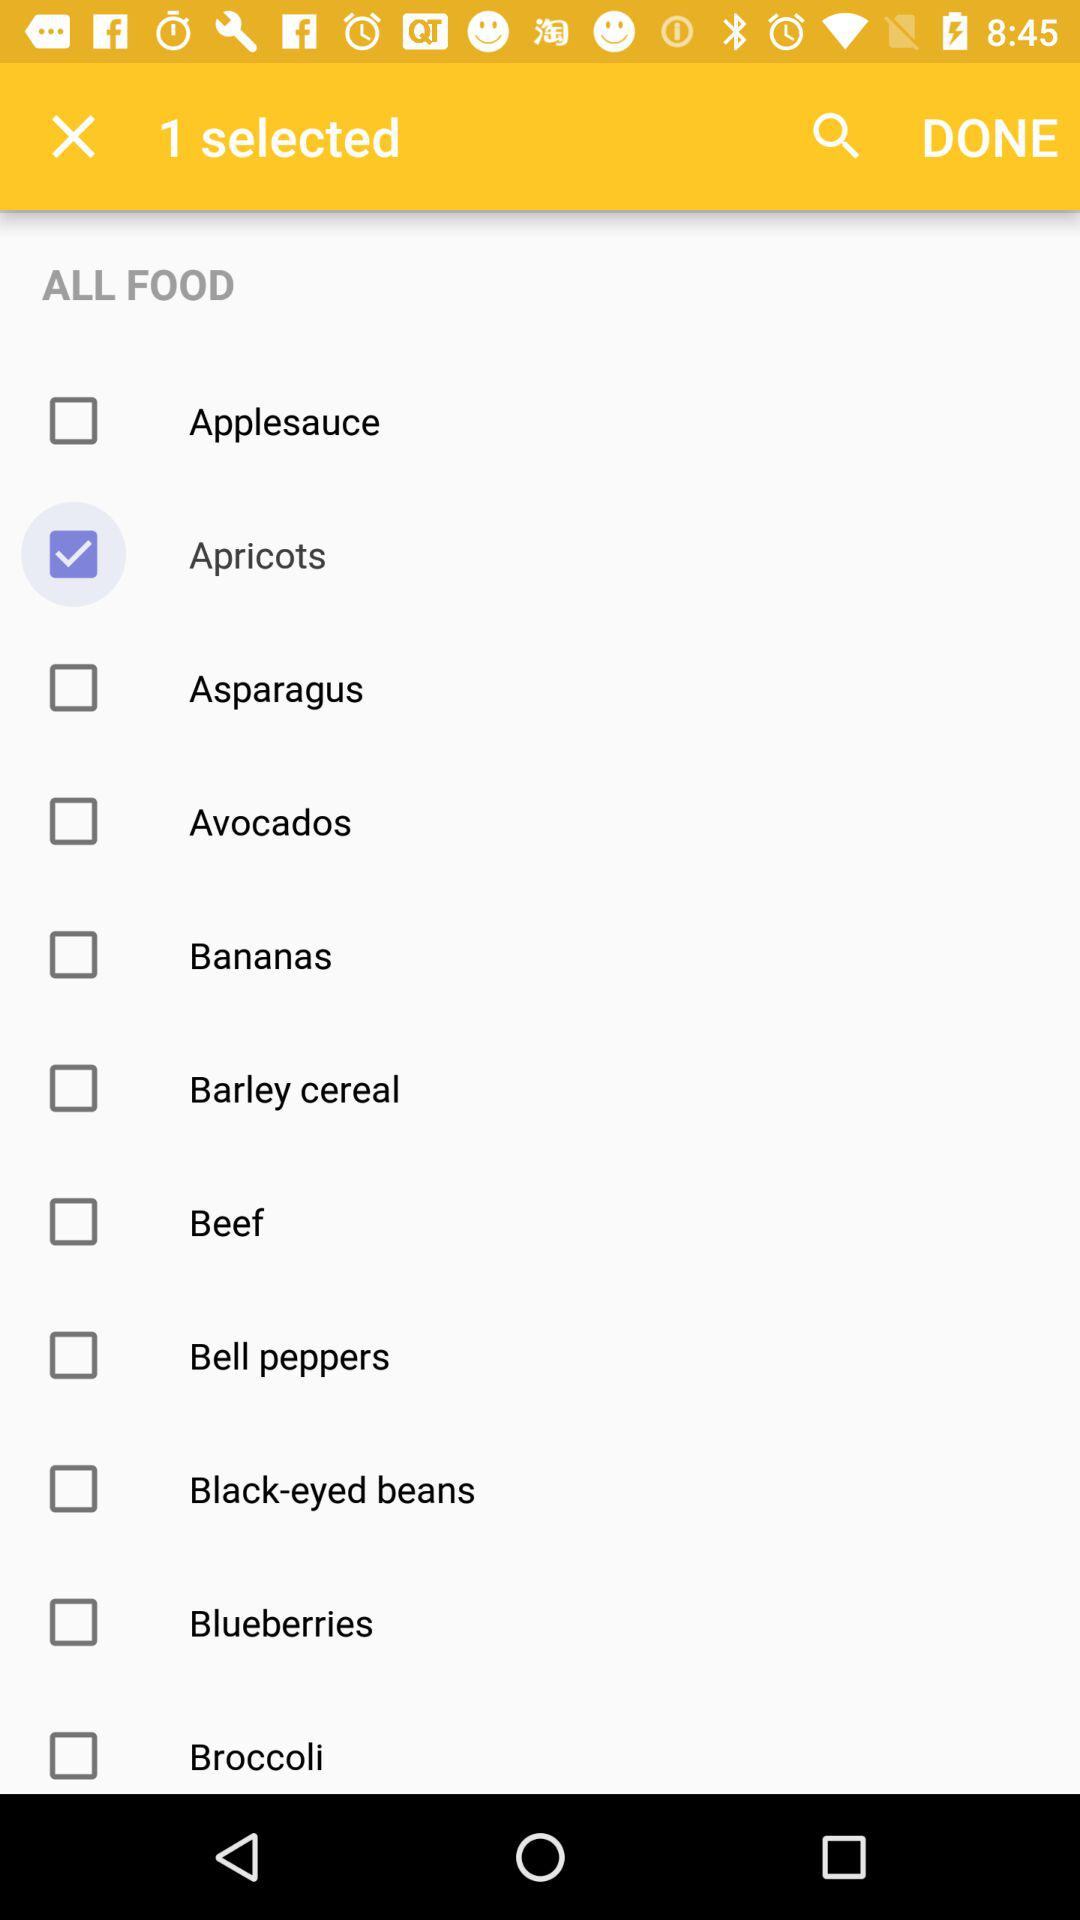How much do apricots cost?
When the provided information is insufficient, respond with <no answer>. <no answer> 